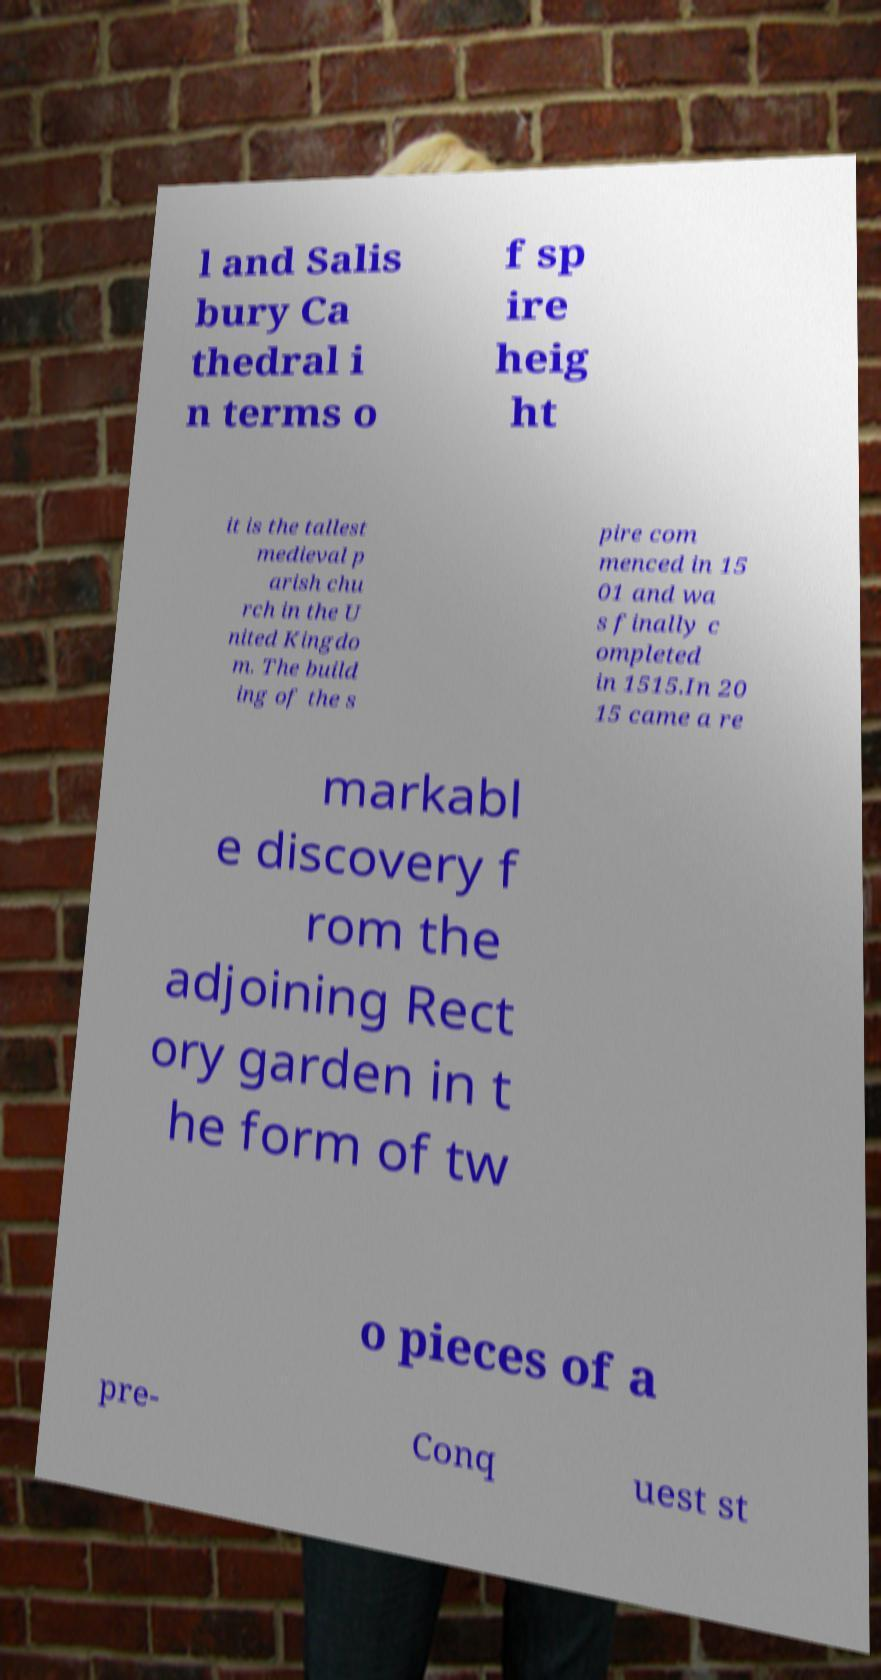There's text embedded in this image that I need extracted. Can you transcribe it verbatim? l and Salis bury Ca thedral i n terms o f sp ire heig ht it is the tallest medieval p arish chu rch in the U nited Kingdo m. The build ing of the s pire com menced in 15 01 and wa s finally c ompleted in 1515.In 20 15 came a re markabl e discovery f rom the adjoining Rect ory garden in t he form of tw o pieces of a pre- Conq uest st 